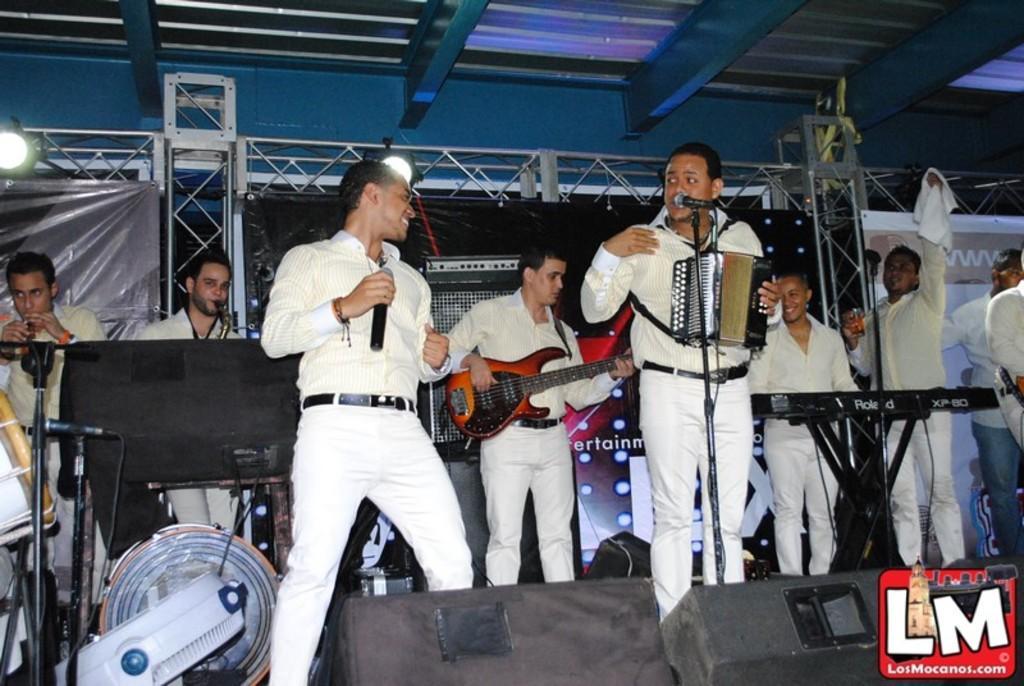Describe this image in one or two sentences. It looks like a music concert ,all the people are standing in the image many of them are playing different musical instruments violin ,piano ,guitar ,some of the singing ,in the background there are iron rods and blue color wall. 